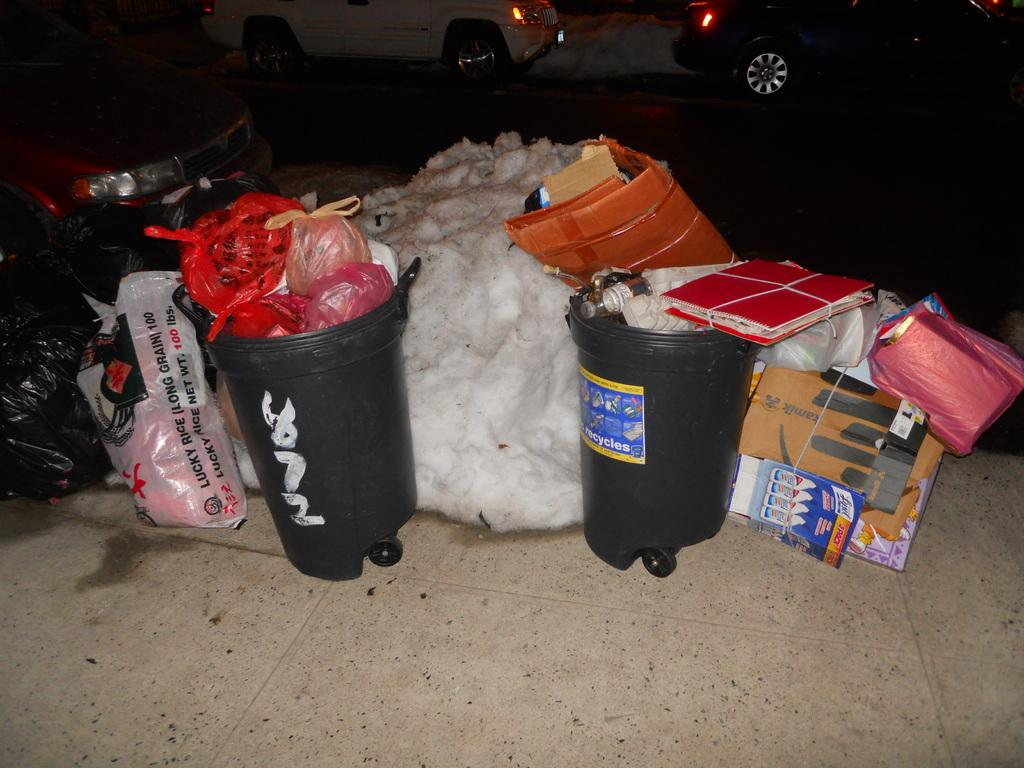Provide a one-sentence caption for the provided image. A pile of trash is on a sidewalk and one of the bags says Lucky Rice. 